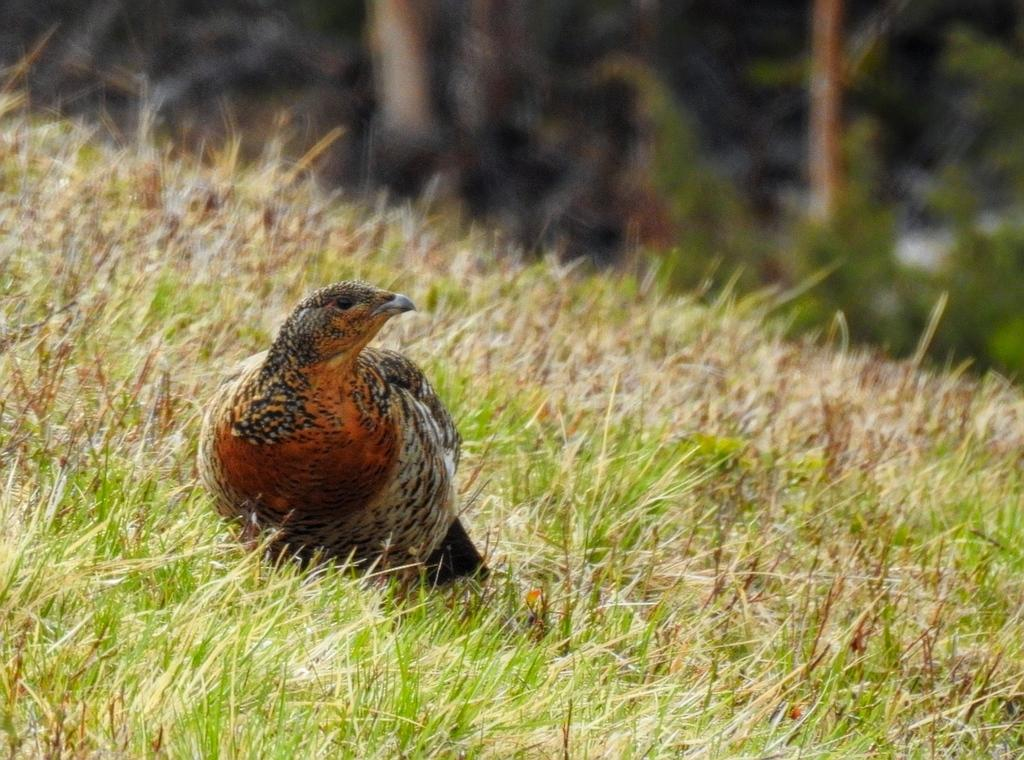What type of animal is on the ground in the image? There is a bird on the ground in the image. What is the ground covered with in the image? There is grass on the ground in the image. Can you describe the top part of the image? The top part of the image is blurry. What does the bird taste like in the image? The image does not provide any information about the taste of the bird, as it is a visual representation and not a sensory experience. 